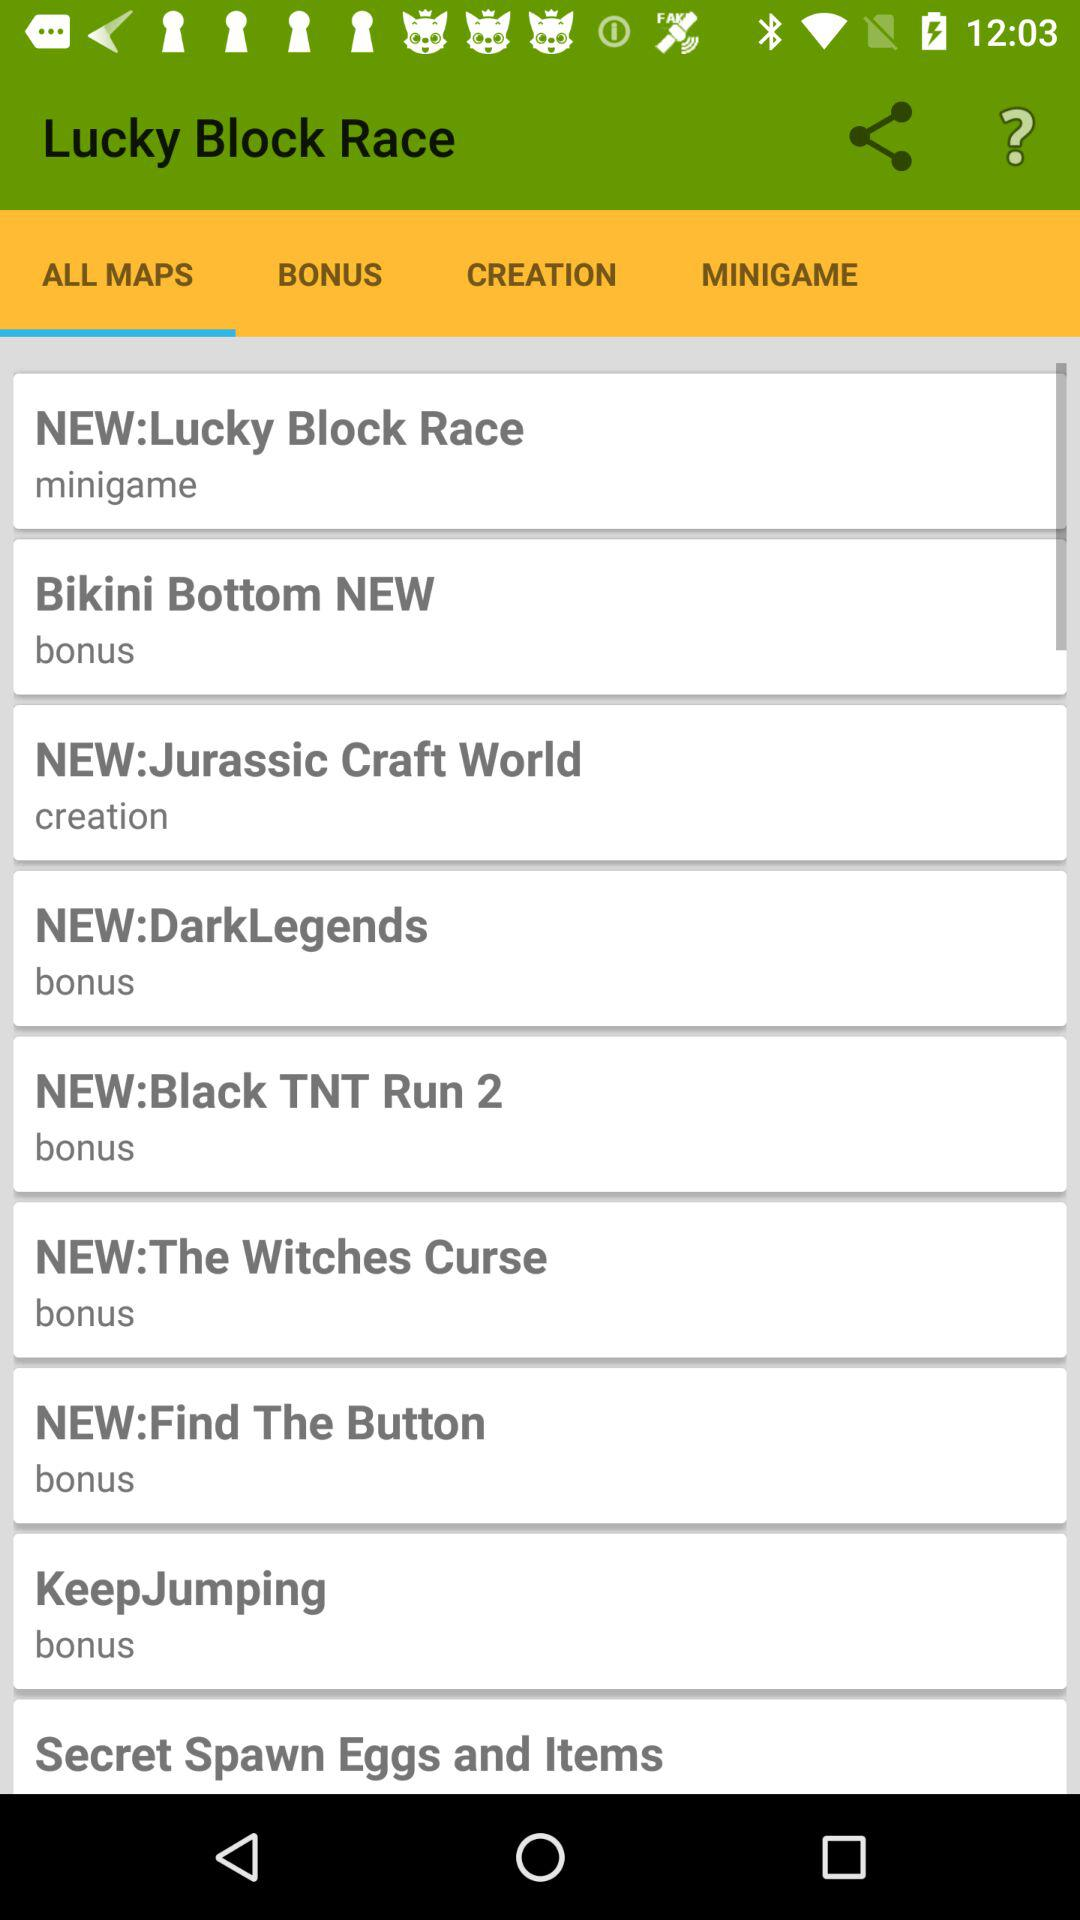Which tab has been selected? The tab that has been selected is "ALL MAPS". 